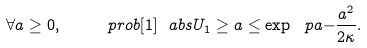Convert formula to latex. <formula><loc_0><loc_0><loc_500><loc_500>\forall a \geq 0 , \quad \ p r o b [ 1 ] { \ a b s { U _ { 1 } } \geq a } \leq \exp \ p a { - \frac { a ^ { 2 } } { 2 \kappa } } .</formula> 